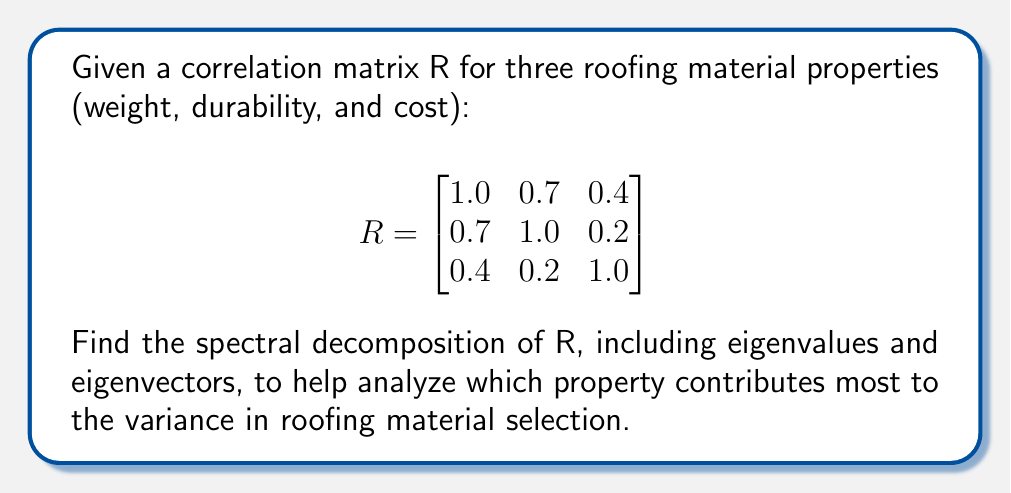Give your solution to this math problem. To find the spectral decomposition of the correlation matrix R, we need to follow these steps:

1. Find the eigenvalues of R by solving the characteristic equation:
   $$\det(R - \lambda I) = 0$$

   $$\begin{vmatrix}
   1-\lambda & 0.7 & 0.4 \\
   0.7 & 1-\lambda & 0.2 \\
   0.4 & 0.2 & 1-\lambda
   \end{vmatrix} = 0$$

   Expanding this determinant:
   $$-\lambda^3 + 3\lambda^2 - 2.27\lambda + 0.468 = 0$$

2. Solve this cubic equation to get the eigenvalues:
   $$\lambda_1 \approx 1.9539, \lambda_2 \approx 0.8161, \lambda_3 \approx 0.2300$$

3. For each eigenvalue, find the corresponding eigenvector by solving:
   $$(R - \lambda_i I)v_i = 0$$

   For $\lambda_1 \approx 1.9539$:
   $$v_1 \approx [0.6124, 0.5792, 0.5380]^T$$

   For $\lambda_2 \approx 0.8161$:
   $$v_2 \approx [-0.3422, -0.1269, 0.9310]^T$$

   For $\lambda_3 \approx 0.2300$:
   $$v_3 \approx [0.7120, -0.7055, 0.0135]^T$$

4. Normalize these eigenvectors to unit length.

5. The spectral decomposition is then:
   $$R = V\Lambda V^T$$

   Where:
   $$V = [v_1 | v_2 | v_3]$$
   $$\Lambda = \text{diag}(\lambda_1, \lambda_2, \lambda_3)$$

The largest eigenvalue (1.9539) corresponds to the direction of maximum variance. Its associated eigenvector shows that weight and durability contribute more to this principal component than cost.
Answer: $R = V\Lambda V^T$, where $V \approx [0.6124, -0.3422, 0.7120; 0.5792, -0.1269, -0.7055; 0.5380, 0.9310, 0.0135]$ and $\Lambda \approx \text{diag}(1.9539, 0.8161, 0.2300)$ 